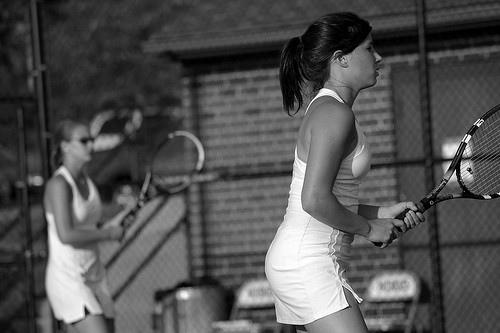Are these professionals?
Keep it brief. No. Is she exercising?
Give a very brief answer. Yes. Is the picture in color?
Concise answer only. No. What are these people doing?
Answer briefly. Playing tennis. 